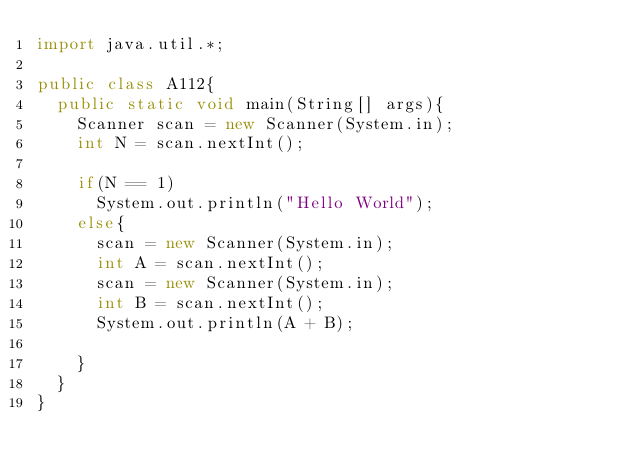Convert code to text. <code><loc_0><loc_0><loc_500><loc_500><_Java_>import java.util.*;

public class A112{
  public static void main(String[] args){
    Scanner scan = new Scanner(System.in);
    int N = scan.nextInt();

    if(N == 1)
      System.out.println("Hello World");
    else{
      scan = new Scanner(System.in);
      int A = scan.nextInt();
      scan = new Scanner(System.in);
      int B = scan.nextInt();
      System.out.println(A + B);

    }
  }
}
</code> 